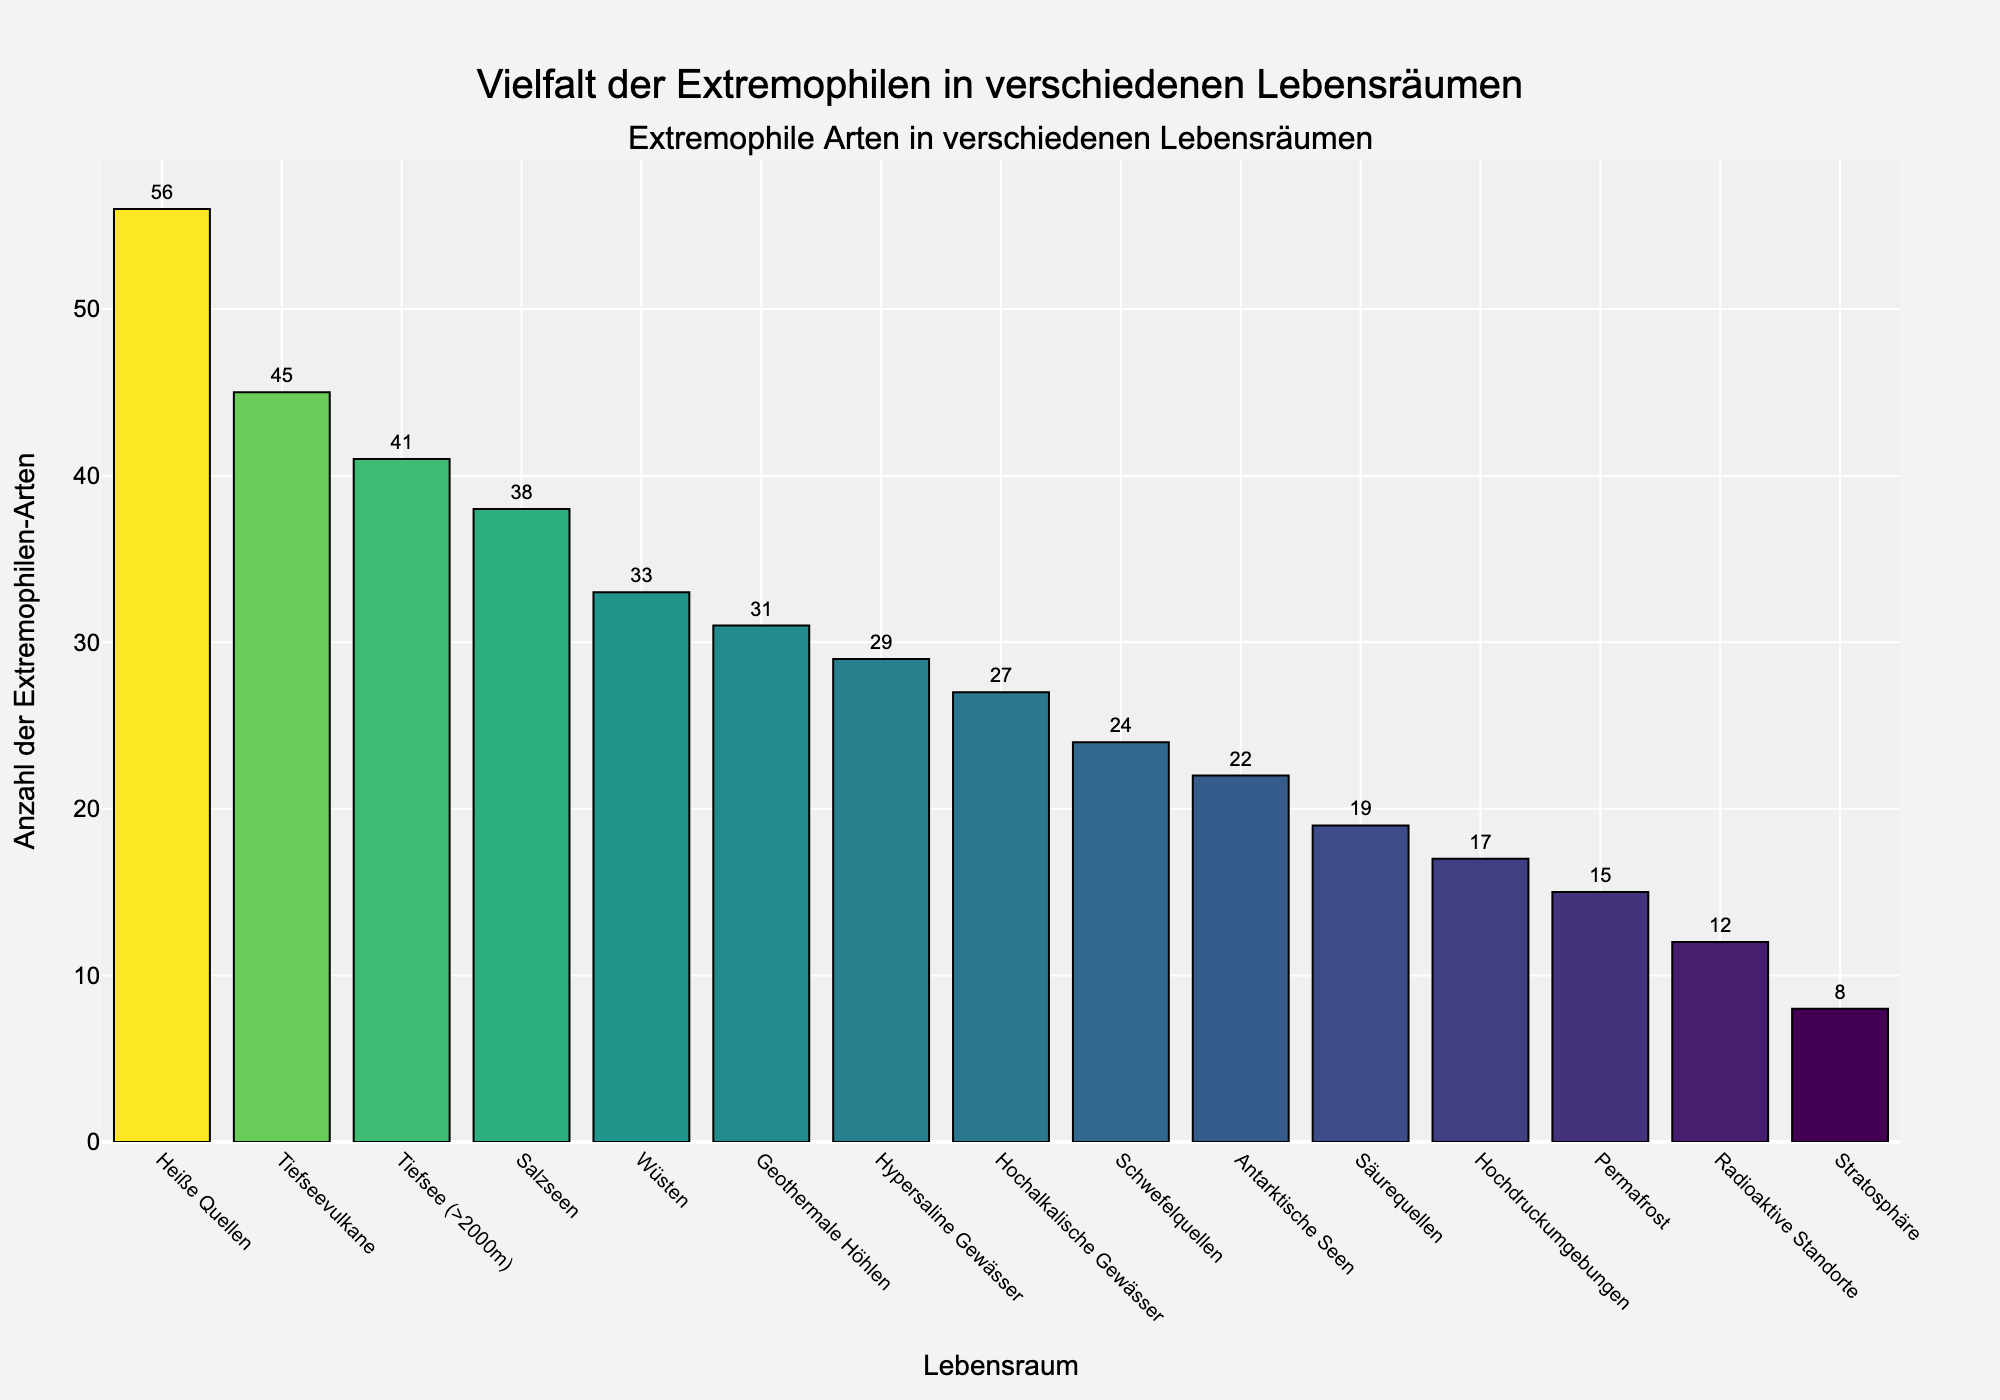Wie viele verschiedenen extremen Lebensräume sind in dem Diagramm dargestellt? In dem Diagramm sind insgesamt 15 verschiedene Lebensräume aufgelistet.
Answer: 15 Welcher Lebensraum hat die höchste Anzahl von Extremophilen-Arten? Der höchste Balken im Diagramm steht für "Heiße Quellen" mit 56 Extremophilen-Arten.
Answer: Heiße Quellen Welche zwei Lebensräume haben die niedrigste Anzahl von Extremophilen-Arten und wie viele Arten sind es jeweils? Die Balken für "Stratosphäre" und "Permafrost" sind am kürzesten, mit jeweils 8 und 15 Extremophilen-Arten.
Answer: Stratosphäre (8), Permafrost (15) Wie viele mehr Arten gibt es in "Heiße Quellen" als in "Salzseen"? "Heiße Quellen" haben 56 Arten und "Salzseen" haben 38 Arten. Die Differenz beträgt 56 - 38 = 18.
Answer: 18 Welche Lebensräume haben zwischen 20 und 30 Extremophilen-Arten? Die Lebensräume zwischen 20 und 30 Arten sind "Antarktische Seen", "Hochalkalische Gewässer", "Hypersaline Gewässer", "Schwefelquellen".
Answer: Antarktische Seen, Hochalkalische Gewässer, Hypersaline Gewässer, Schwefelquellen Welche drei Lebensräume haben die nächsthöchste Anzahl von Extremophilen-Arten nach "Heiße Quellen"? Nach "Heiße Quellen" (56 Arten), haben "Tiefseevulkane" (45 Arten), "Tiefsee (>2000m)" (41 Arten) und "Salzseen" (38 Arten) die nächsthöchsten Werte.
Answer: Tiefseevulkane (45), Tiefsee (>2000m) (41), Salzseen (38) Wie viele mehr Arten gibt es in "Geothermale Höhlen" als in "Radioaktive Standorte"? "Geothermale Höhlen" haben 31 Arten und "Radioaktive Standorte" haben 12 Arten. Die Differenz beträgt 31 - 12 = 19.
Answer: 19 Welcher Lebensraum zeigt eine Anzahl von Extremophilen-Arten, die etwa in der Mittel der Verteilung liegt? Der Lebensraum "Hochalkalische Gewässer" zeigt mit 27 Arten eine Anzahl, die zwischen den Extremen liegt.
Answer: Hochalkalische Gewässer Welche Lebensräume haben weniger als 20 Extremophilen-Arten? "Permafrost", "Radioaktive Standorte" und "Stratosphäre" haben jeweils weniger als 20 Arten, mit Werten von 15, 12 und 8.
Answer: Permafrost, Radioaktive Standorte, Stratosphäre 